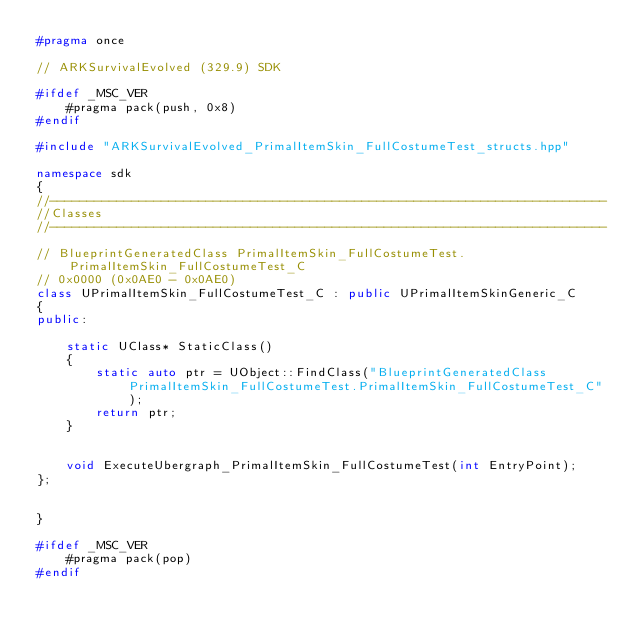<code> <loc_0><loc_0><loc_500><loc_500><_C++_>#pragma once

// ARKSurvivalEvolved (329.9) SDK

#ifdef _MSC_VER
	#pragma pack(push, 0x8)
#endif

#include "ARKSurvivalEvolved_PrimalItemSkin_FullCostumeTest_structs.hpp"

namespace sdk
{
//---------------------------------------------------------------------------
//Classes
//---------------------------------------------------------------------------

// BlueprintGeneratedClass PrimalItemSkin_FullCostumeTest.PrimalItemSkin_FullCostumeTest_C
// 0x0000 (0x0AE0 - 0x0AE0)
class UPrimalItemSkin_FullCostumeTest_C : public UPrimalItemSkinGeneric_C
{
public:

	static UClass* StaticClass()
	{
		static auto ptr = UObject::FindClass("BlueprintGeneratedClass PrimalItemSkin_FullCostumeTest.PrimalItemSkin_FullCostumeTest_C");
		return ptr;
	}


	void ExecuteUbergraph_PrimalItemSkin_FullCostumeTest(int EntryPoint);
};


}

#ifdef _MSC_VER
	#pragma pack(pop)
#endif
</code> 